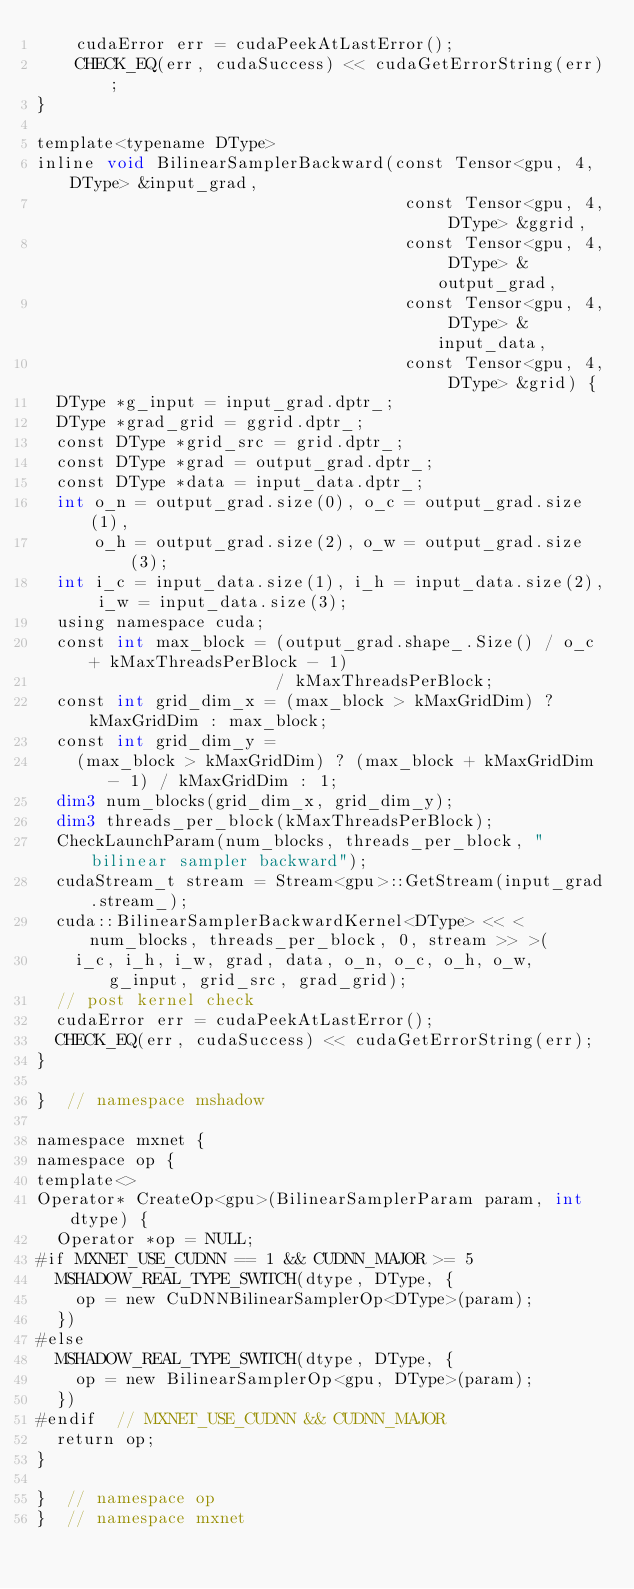<code> <loc_0><loc_0><loc_500><loc_500><_Cuda_>    cudaError err = cudaPeekAtLastError();
    CHECK_EQ(err, cudaSuccess) << cudaGetErrorString(err);
}

template<typename DType>
inline void BilinearSamplerBackward(const Tensor<gpu, 4, DType> &input_grad,
                                     const Tensor<gpu, 4, DType> &ggrid,
                                     const Tensor<gpu, 4, DType> &output_grad,
                                     const Tensor<gpu, 4, DType> &input_data,
                                     const Tensor<gpu, 4, DType> &grid) {
  DType *g_input = input_grad.dptr_;
  DType *grad_grid = ggrid.dptr_;
  const DType *grid_src = grid.dptr_;
  const DType *grad = output_grad.dptr_;
  const DType *data = input_data.dptr_;
  int o_n = output_grad.size(0), o_c = output_grad.size(1),
      o_h = output_grad.size(2), o_w = output_grad.size(3);
  int i_c = input_data.size(1), i_h = input_data.size(2), i_w = input_data.size(3);
  using namespace cuda;
  const int max_block = (output_grad.shape_.Size() / o_c + kMaxThreadsPerBlock - 1)
                        / kMaxThreadsPerBlock;
  const int grid_dim_x = (max_block > kMaxGridDim) ? kMaxGridDim : max_block;
  const int grid_dim_y =
    (max_block > kMaxGridDim) ? (max_block + kMaxGridDim - 1) / kMaxGridDim : 1;
  dim3 num_blocks(grid_dim_x, grid_dim_y);
  dim3 threads_per_block(kMaxThreadsPerBlock);
  CheckLaunchParam(num_blocks, threads_per_block, "bilinear sampler backward");
  cudaStream_t stream = Stream<gpu>::GetStream(input_grad.stream_);
  cuda::BilinearSamplerBackwardKernel<DType> << <num_blocks, threads_per_block, 0, stream >> >(
    i_c, i_h, i_w, grad, data, o_n, o_c, o_h, o_w, g_input, grid_src, grad_grid);
  // post kernel check
  cudaError err = cudaPeekAtLastError();
  CHECK_EQ(err, cudaSuccess) << cudaGetErrorString(err);
}

}  // namespace mshadow

namespace mxnet {
namespace op {
template<>
Operator* CreateOp<gpu>(BilinearSamplerParam param, int dtype) {
  Operator *op = NULL;
#if MXNET_USE_CUDNN == 1 && CUDNN_MAJOR >= 5
  MSHADOW_REAL_TYPE_SWITCH(dtype, DType, {
    op = new CuDNNBilinearSamplerOp<DType>(param);
  })
#else
  MSHADOW_REAL_TYPE_SWITCH(dtype, DType, {
    op = new BilinearSamplerOp<gpu, DType>(param);
  })
#endif  // MXNET_USE_CUDNN && CUDNN_MAJOR
  return op;
}

}  // namespace op
}  // namespace mxnet
</code> 